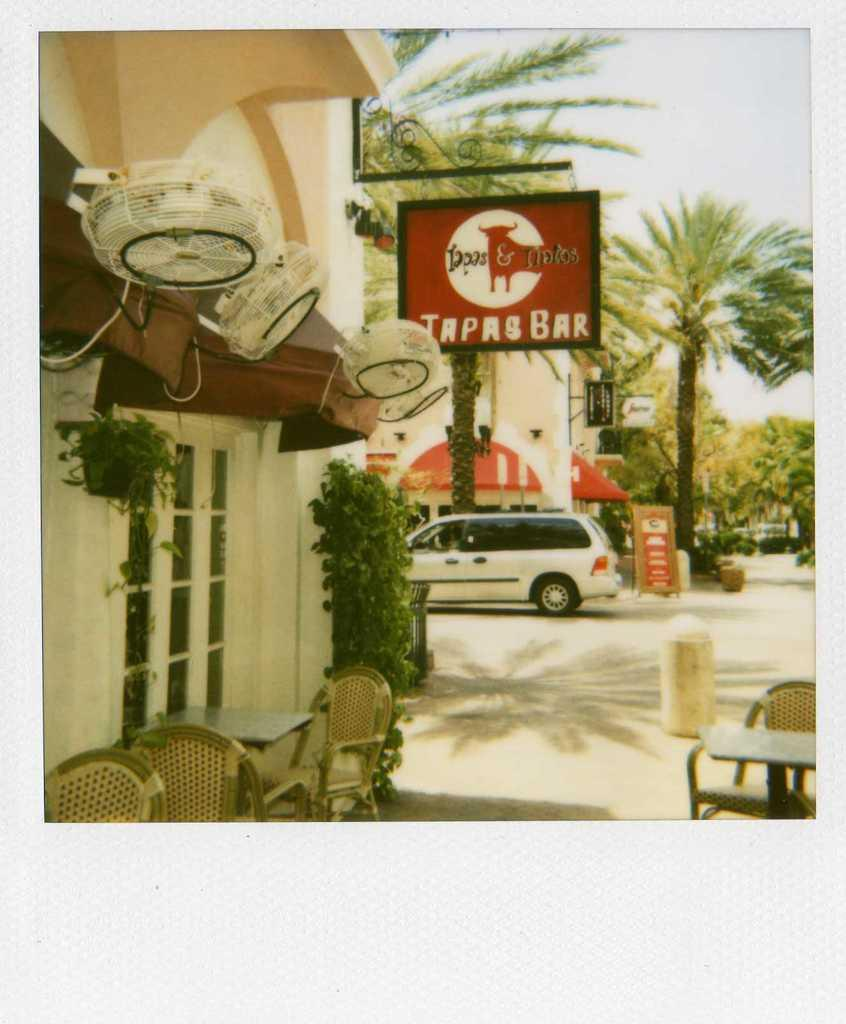What is the main subject of the image? The main subject of the image is a photograph. What objects can be seen in the photograph? The photograph contains chairs, tables, flower pots, windows, fans, a board, a car parked on the road, buildings, and trees. What is visible in the background of the photograph? The sky is visible in the background of the photograph. What type of screw can be seen holding the underwear on the clothesline in the image? There is no screw or underwear present in the image. The image contains a photograph with various objects and elements, but none of them include a screw or underwear. Is there a party happening in the image? There is no indication of a party in the image. The image contains a photograph with various objects and elements, but none of them suggest a party is taking place. 